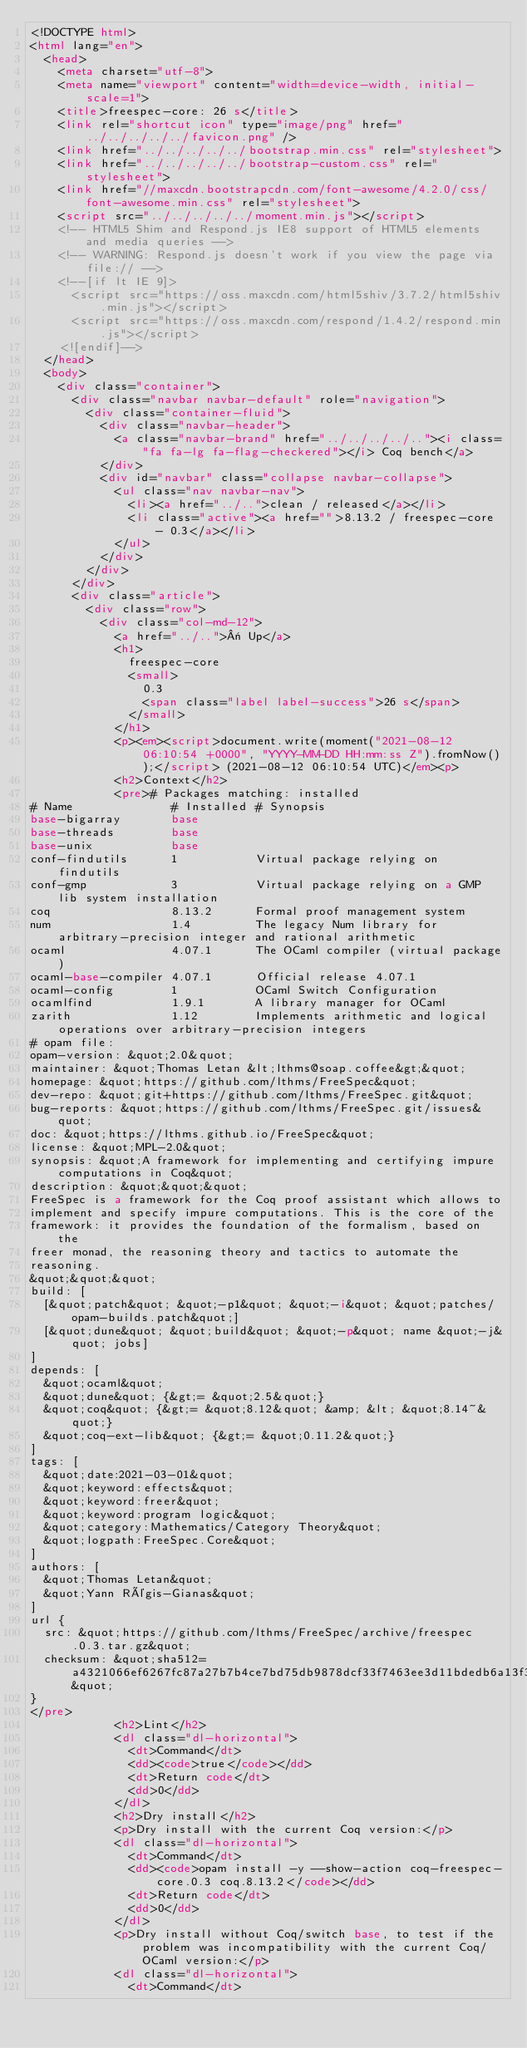<code> <loc_0><loc_0><loc_500><loc_500><_HTML_><!DOCTYPE html>
<html lang="en">
  <head>
    <meta charset="utf-8">
    <meta name="viewport" content="width=device-width, initial-scale=1">
    <title>freespec-core: 26 s</title>
    <link rel="shortcut icon" type="image/png" href="../../../../../favicon.png" />
    <link href="../../../../../bootstrap.min.css" rel="stylesheet">
    <link href="../../../../../bootstrap-custom.css" rel="stylesheet">
    <link href="//maxcdn.bootstrapcdn.com/font-awesome/4.2.0/css/font-awesome.min.css" rel="stylesheet">
    <script src="../../../../../moment.min.js"></script>
    <!-- HTML5 Shim and Respond.js IE8 support of HTML5 elements and media queries -->
    <!-- WARNING: Respond.js doesn't work if you view the page via file:// -->
    <!--[if lt IE 9]>
      <script src="https://oss.maxcdn.com/html5shiv/3.7.2/html5shiv.min.js"></script>
      <script src="https://oss.maxcdn.com/respond/1.4.2/respond.min.js"></script>
    <![endif]-->
  </head>
  <body>
    <div class="container">
      <div class="navbar navbar-default" role="navigation">
        <div class="container-fluid">
          <div class="navbar-header">
            <a class="navbar-brand" href="../../../../.."><i class="fa fa-lg fa-flag-checkered"></i> Coq bench</a>
          </div>
          <div id="navbar" class="collapse navbar-collapse">
            <ul class="nav navbar-nav">
              <li><a href="../..">clean / released</a></li>
              <li class="active"><a href="">8.13.2 / freespec-core - 0.3</a></li>
            </ul>
          </div>
        </div>
      </div>
      <div class="article">
        <div class="row">
          <div class="col-md-12">
            <a href="../..">« Up</a>
            <h1>
              freespec-core
              <small>
                0.3
                <span class="label label-success">26 s</span>
              </small>
            </h1>
            <p><em><script>document.write(moment("2021-08-12 06:10:54 +0000", "YYYY-MM-DD HH:mm:ss Z").fromNow());</script> (2021-08-12 06:10:54 UTC)</em><p>
            <h2>Context</h2>
            <pre># Packages matching: installed
# Name              # Installed # Synopsis
base-bigarray       base
base-threads        base
base-unix           base
conf-findutils      1           Virtual package relying on findutils
conf-gmp            3           Virtual package relying on a GMP lib system installation
coq                 8.13.2      Formal proof management system
num                 1.4         The legacy Num library for arbitrary-precision integer and rational arithmetic
ocaml               4.07.1      The OCaml compiler (virtual package)
ocaml-base-compiler 4.07.1      Official release 4.07.1
ocaml-config        1           OCaml Switch Configuration
ocamlfind           1.9.1       A library manager for OCaml
zarith              1.12        Implements arithmetic and logical operations over arbitrary-precision integers
# opam file:
opam-version: &quot;2.0&quot;
maintainer: &quot;Thomas Letan &lt;lthms@soap.coffee&gt;&quot;
homepage: &quot;https://github.com/lthms/FreeSpec&quot;
dev-repo: &quot;git+https://github.com/lthms/FreeSpec.git&quot;
bug-reports: &quot;https://github.com/lthms/FreeSpec.git/issues&quot;
doc: &quot;https://lthms.github.io/FreeSpec&quot;
license: &quot;MPL-2.0&quot;
synopsis: &quot;A framework for implementing and certifying impure computations in Coq&quot;
description: &quot;&quot;&quot;
FreeSpec is a framework for the Coq proof assistant which allows to
implement and specify impure computations. This is the core of the
framework: it provides the foundation of the formalism, based on the
freer monad, the reasoning theory and tactics to automate the
reasoning.
&quot;&quot;&quot;
build: [
  [&quot;patch&quot; &quot;-p1&quot; &quot;-i&quot; &quot;patches/opam-builds.patch&quot;]
  [&quot;dune&quot; &quot;build&quot; &quot;-p&quot; name &quot;-j&quot; jobs]
]
depends: [
  &quot;ocaml&quot;
  &quot;dune&quot; {&gt;= &quot;2.5&quot;}
  &quot;coq&quot; {&gt;= &quot;8.12&quot; &amp; &lt; &quot;8.14~&quot;}
  &quot;coq-ext-lib&quot; {&gt;= &quot;0.11.2&quot;}
]
tags: [
  &quot;date:2021-03-01&quot;
  &quot;keyword:effects&quot;
  &quot;keyword:freer&quot;
  &quot;keyword:program logic&quot;
  &quot;category:Mathematics/Category Theory&quot;
  &quot;logpath:FreeSpec.Core&quot;
]
authors: [
  &quot;Thomas Letan&quot;
  &quot;Yann Régis-Gianas&quot;
]
url {
  src: &quot;https://github.com/lthms/FreeSpec/archive/freespec.0.3.tar.gz&quot;
  checksum: &quot;sha512=a4321066ef6267fc87a27b7b4ce7bd75db9878dcf33f7463ee3d11bdedb6a13f30008f7c20ca972c18e7d6f3bf8b0857409caf7fad60ecbd186e83b45fa1b7a1&quot;
}
</pre>
            <h2>Lint</h2>
            <dl class="dl-horizontal">
              <dt>Command</dt>
              <dd><code>true</code></dd>
              <dt>Return code</dt>
              <dd>0</dd>
            </dl>
            <h2>Dry install</h2>
            <p>Dry install with the current Coq version:</p>
            <dl class="dl-horizontal">
              <dt>Command</dt>
              <dd><code>opam install -y --show-action coq-freespec-core.0.3 coq.8.13.2</code></dd>
              <dt>Return code</dt>
              <dd>0</dd>
            </dl>
            <p>Dry install without Coq/switch base, to test if the problem was incompatibility with the current Coq/OCaml version:</p>
            <dl class="dl-horizontal">
              <dt>Command</dt></code> 